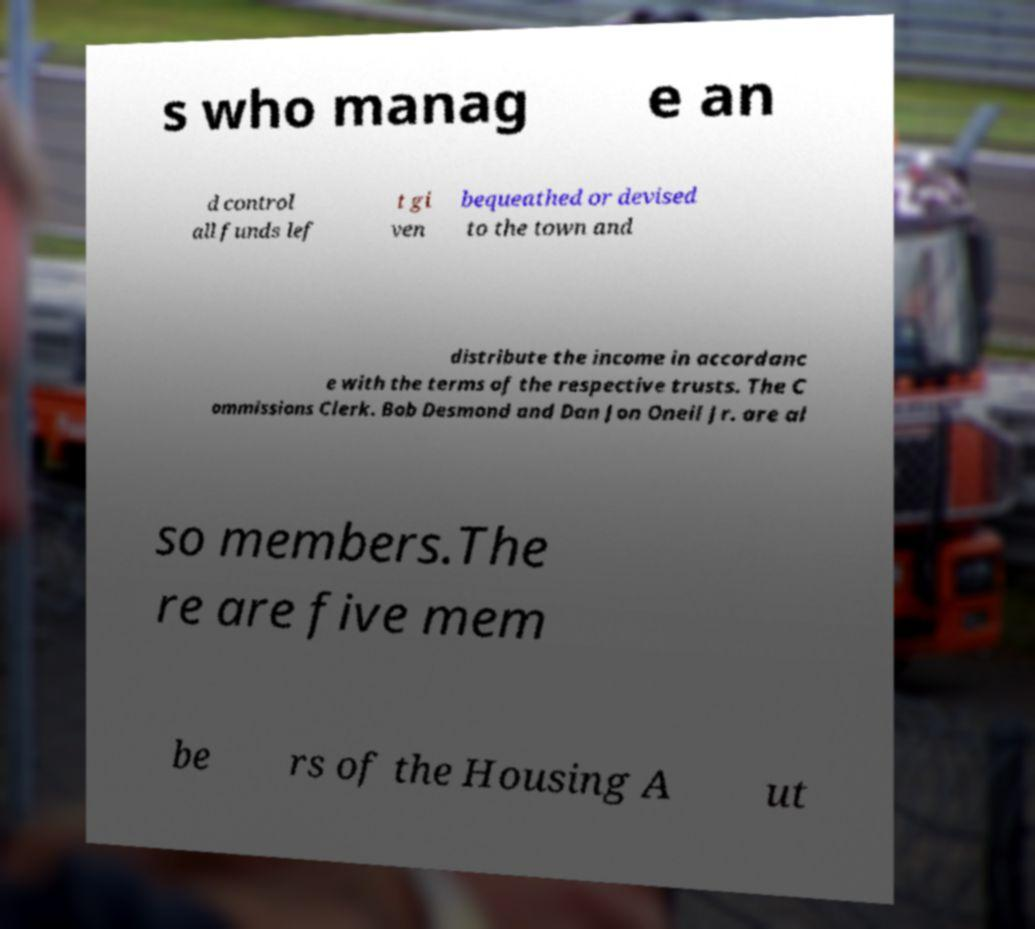Can you read and provide the text displayed in the image?This photo seems to have some interesting text. Can you extract and type it out for me? s who manag e an d control all funds lef t gi ven bequeathed or devised to the town and distribute the income in accordanc e with the terms of the respective trusts. The C ommissions Clerk. Bob Desmond and Dan Jon Oneil Jr. are al so members.The re are five mem be rs of the Housing A ut 